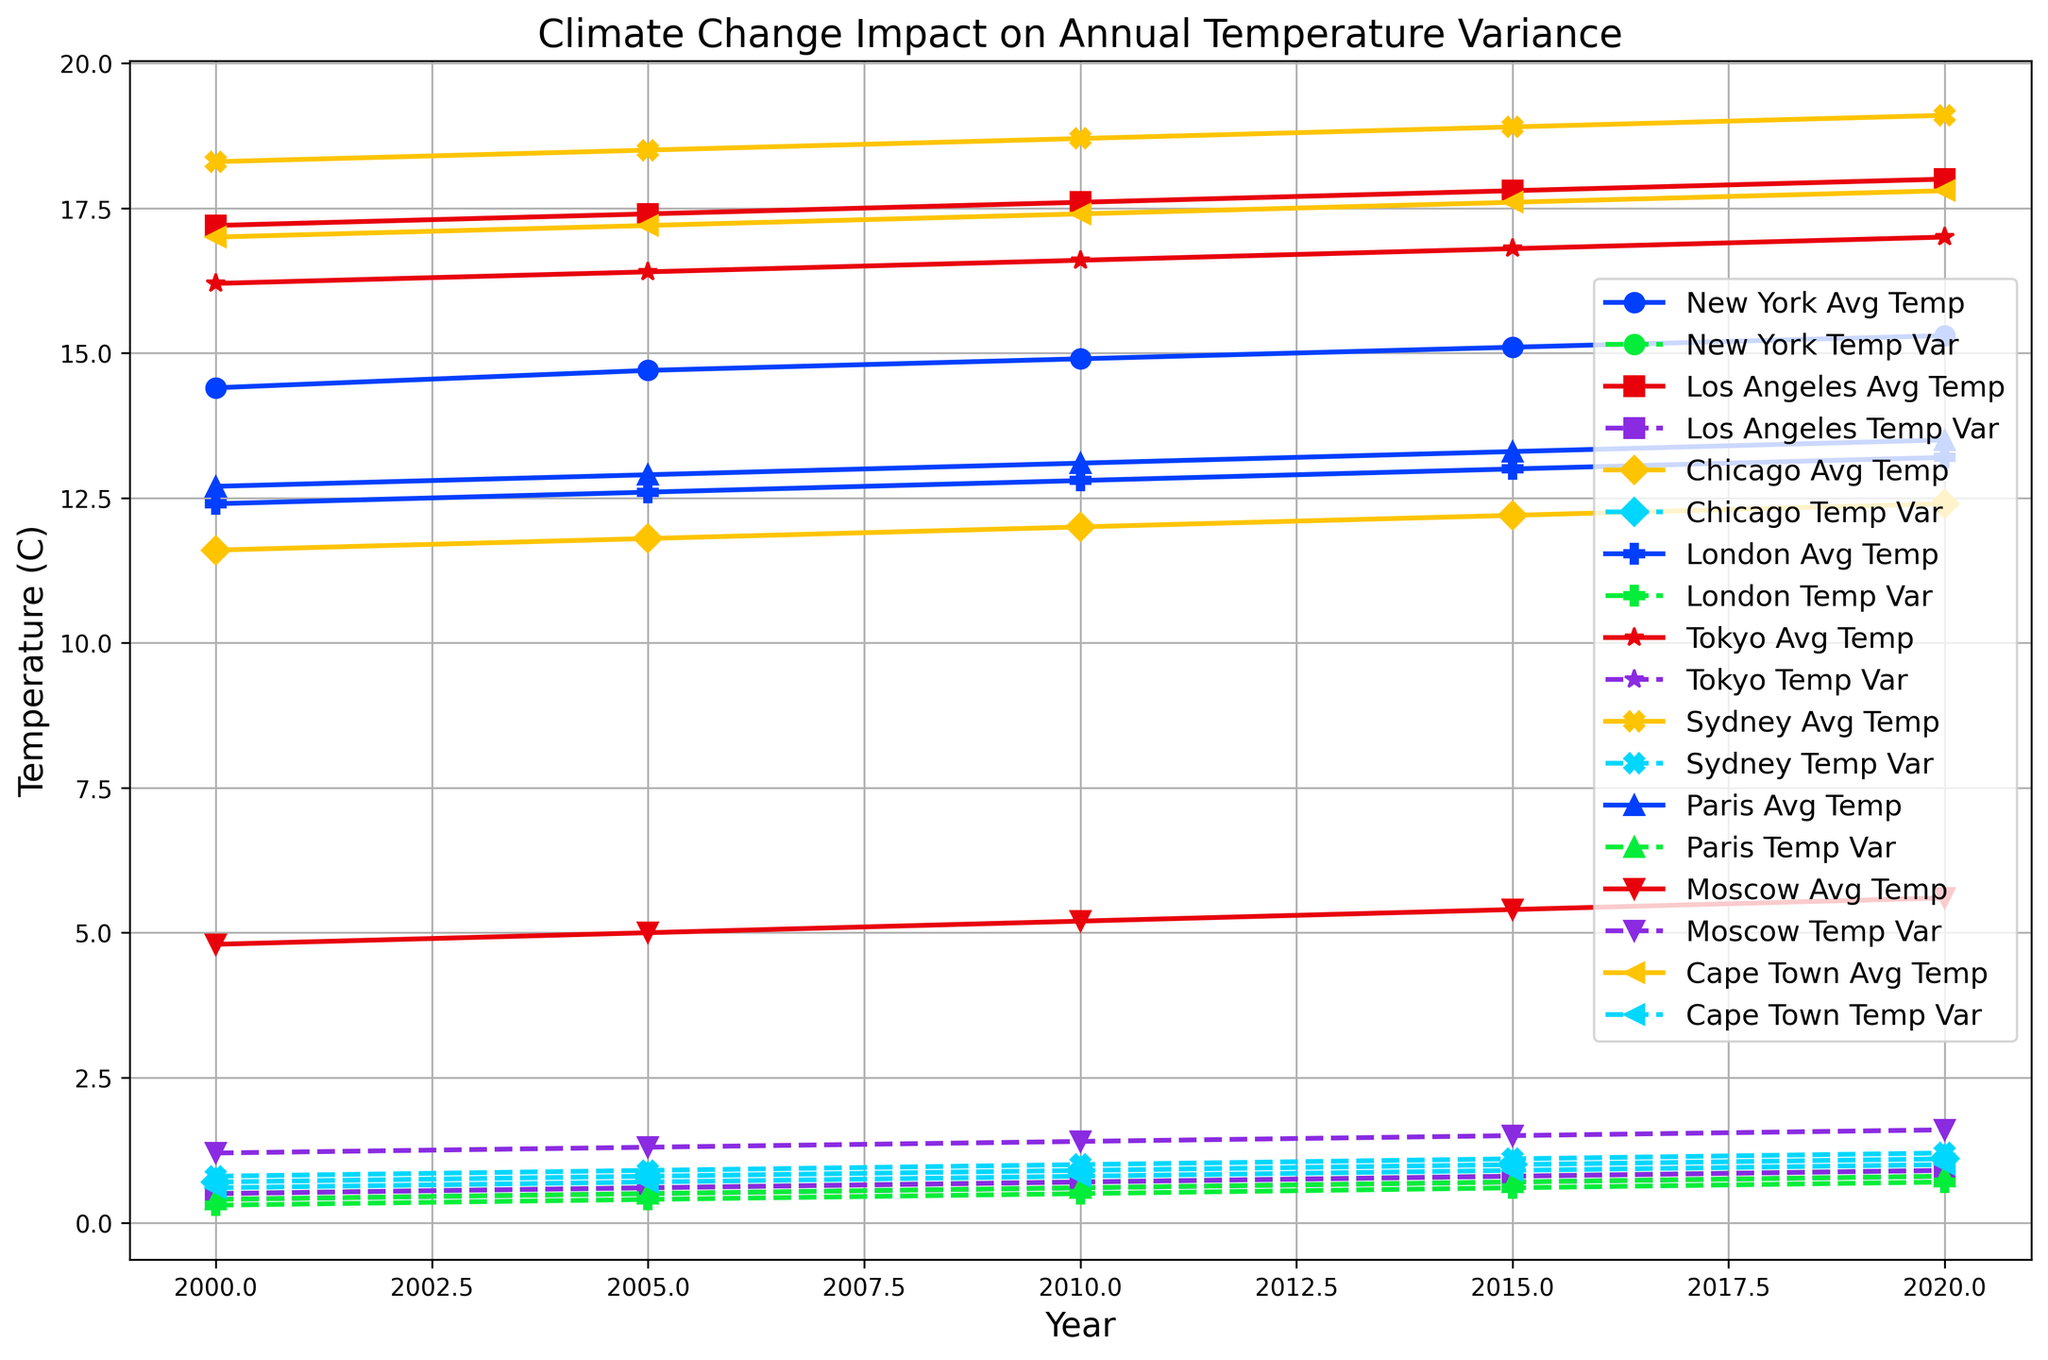Which city exhibits the highest average temperature in 2020? By examining the plotted lines, we can identify the city labeled with the highest point in 2020. Sydney has the highest average temperature at 19.1°C.
Answer: Sydney Which city's temperature variance increased the most from 2000 to 2020? To determine the city with the highest increase in temperature variance, we look at the difference in the variance from 2000 to 2020 for each city. Moscow shows the largest increase, going from 1.2 to 1.6, a difference of 0.4.
Answer: Moscow Compare the average temperature of New York and Los Angeles in 2015. Which city was warmer? We compare the y-values for New York and Los Angeles in 2015. New York's average temperature was 15.1°C, while Los Angeles' was 17.8°C. Los Angeles was warmer.
Answer: Los Angeles What is the overall trend in temperature variance for Sydney from 2000 to 2020? Observing the line plotted for Sydney's temperature variance, we see a steadily increasing trend from 0.8 in 2000 to 1.2 in 2020.
Answer: Increasing How much did the average temperature in Tokyo change from 2000 to 2020? Calculate the difference between Tokyo's average temperature in 2020 and 2000. The values are 17.0°C in 2020 and 16.2°C in 2000. The change is 17.0 - 16.2 = 0.8°C.
Answer: 0.8°C Which city had the smallest temperature variance in 2000? Looking at the plotted points for temperature variance in 2000, London had the smallest variance at 0.3.
Answer: London What does the pattern of temperature variance over time in Moscow suggest? Moscow's temperature variance line shows a continual increase from 2000 to 2020, suggesting that temperature variability is growing annually.
Answer: Increasing variability Is the temperature variance of Cape Town in 2020 higher than its average temperature in 2000? Compare Cape Town's temperature variance of 1.0 in 2020 to its average temperature of 17.0 in 2000. The average temperature in 2000 is much higher.
Answer: No How did Paris's average temperature trend from 2000 to 2020? The plotted line for Paris's average temperature shows a gradual increase from 12.7°C in 2000 to 13.5°C in 2020.
Answer: Increasing Which city showed the most stable temperature variance from 2000 to 2020? By examining the temperature variance lines, London shows the most stability with the smallest overall increase (0.3 to 0.7).
Answer: London 